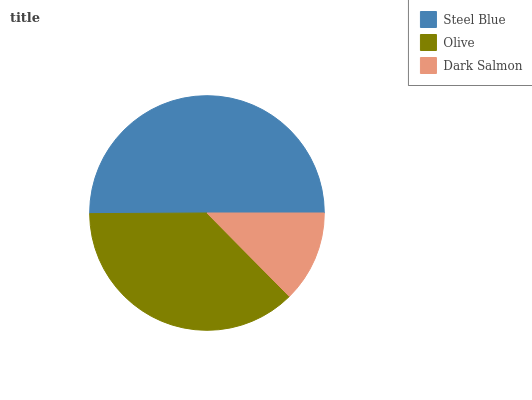Is Dark Salmon the minimum?
Answer yes or no. Yes. Is Steel Blue the maximum?
Answer yes or no. Yes. Is Olive the minimum?
Answer yes or no. No. Is Olive the maximum?
Answer yes or no. No. Is Steel Blue greater than Olive?
Answer yes or no. Yes. Is Olive less than Steel Blue?
Answer yes or no. Yes. Is Olive greater than Steel Blue?
Answer yes or no. No. Is Steel Blue less than Olive?
Answer yes or no. No. Is Olive the high median?
Answer yes or no. Yes. Is Olive the low median?
Answer yes or no. Yes. Is Steel Blue the high median?
Answer yes or no. No. Is Steel Blue the low median?
Answer yes or no. No. 